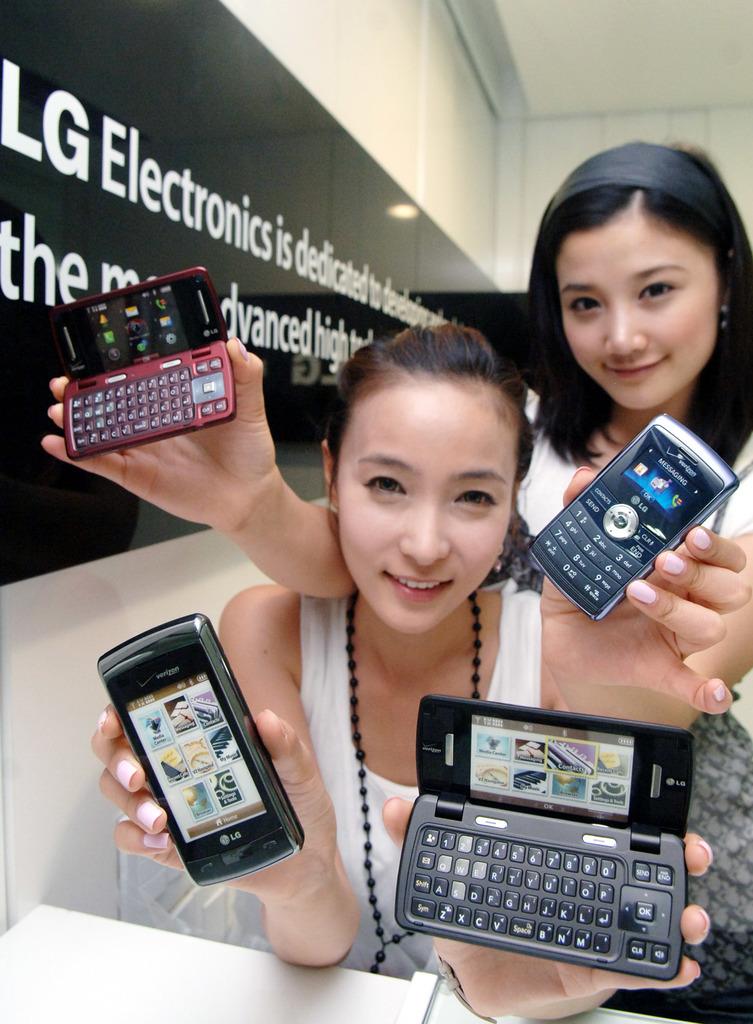What store are they at?
Give a very brief answer. Lg. What service do these phones run on?
Make the answer very short. Verizon. 